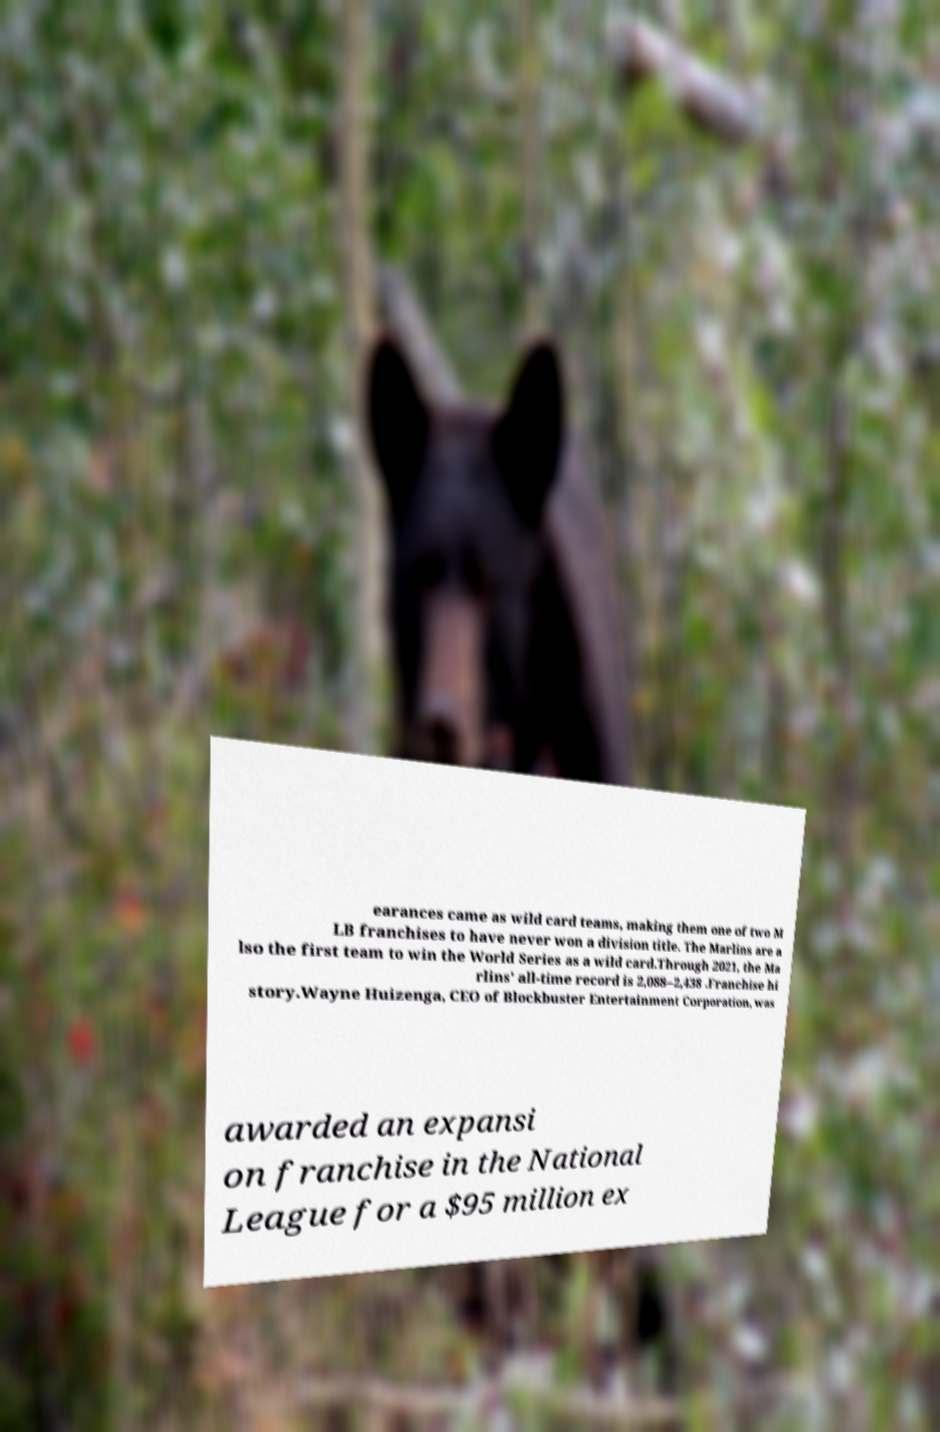I need the written content from this picture converted into text. Can you do that? earances came as wild card teams, making them one of two M LB franchises to have never won a division title. The Marlins are a lso the first team to win the World Series as a wild card.Through 2021, the Ma rlins' all-time record is 2,088–2,438 .Franchise hi story.Wayne Huizenga, CEO of Blockbuster Entertainment Corporation, was awarded an expansi on franchise in the National League for a $95 million ex 